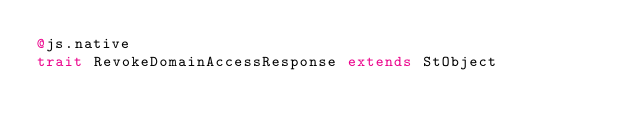<code> <loc_0><loc_0><loc_500><loc_500><_Scala_>@js.native
trait RevokeDomainAccessResponse extends StObject
</code> 